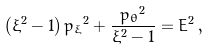<formula> <loc_0><loc_0><loc_500><loc_500>\left ( { \xi } ^ { 2 } - 1 \right ) { p _ { \xi } } ^ { 2 } + \frac { { p _ { \theta } } ^ { 2 } } { { \xi } ^ { 2 } - 1 } = E ^ { 2 } \, ,</formula> 